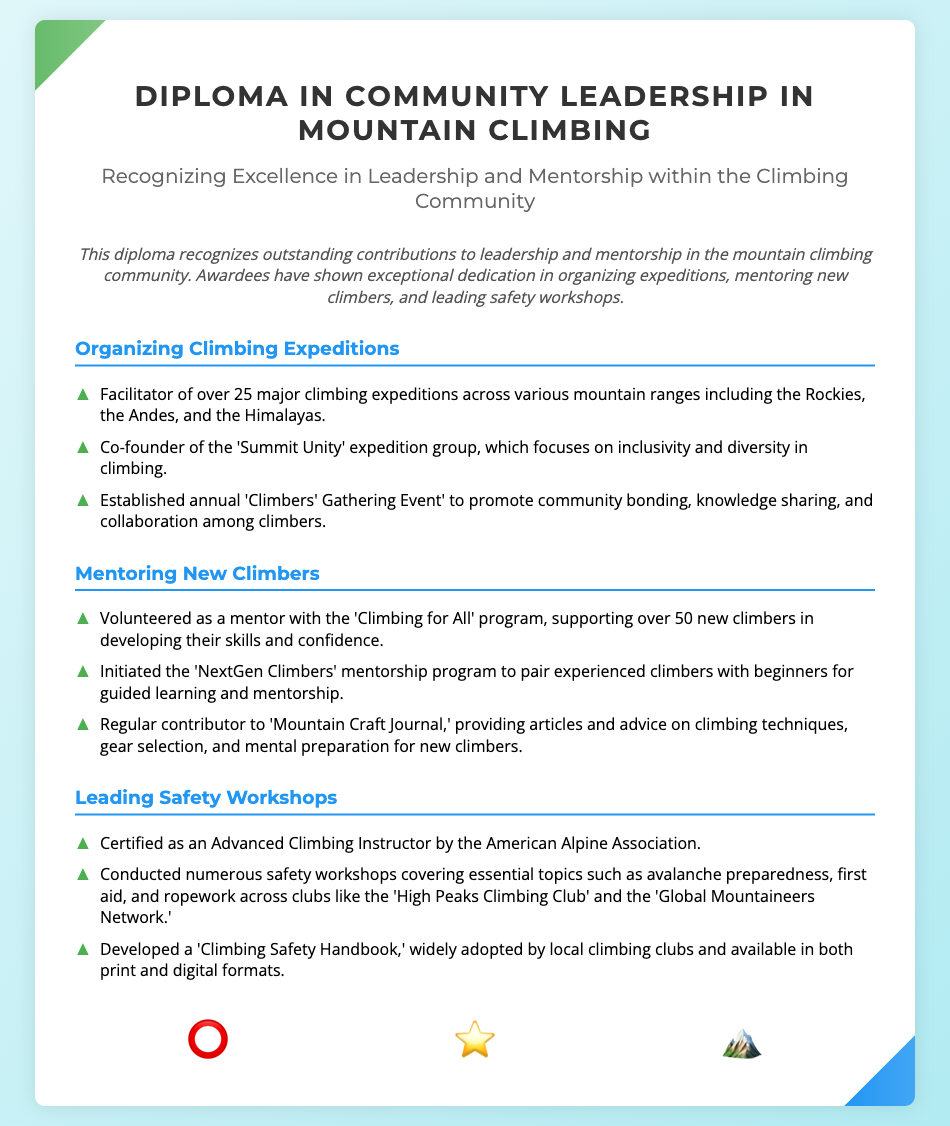What is the title of the diploma? The title of the diploma is prominently displayed at the top of the document.
Answer: Diploma in Community Leadership in Mountain Climbing How many major climbing expeditions has the facilitator organized? The document states that the facilitator has organized over 25 major climbing expeditions.
Answer: Over 25 What program supports new climbers developing their skills? The document mentions a specific program aimed at aiding new climbers.
Answer: Climbing for All What certification has been achieved by the individual recognized in this diploma? The document details a specific certification related to climbing safety.
Answer: Advanced Climbing Instructor Which expedition group focuses on inclusivity and diversity? The diploma highlights the name of a specific expedition group promoting inclusivity.
Answer: Summit Unity How many new climbers has the mentoring program supported? The document gives the number of new climbers supported by the mentoring initiative.
Answer: Over 50 What is the purpose of the 'Climbers' Gathering Event'? The document describes the main aim of this community-focused event.
Answer: Promote community bonding Which clubs have hosted safety workshops? The document lists specific clubs associated with the safety workshops conducted.
Answer: High Peaks Climbing Club, Global Mountaineers Network What type of design motifs are featured in the diploma? The design motifs that enhance the visual aspect of the diploma are specified.
Answer: Community-oriented motifs and symbols of guidance and support 